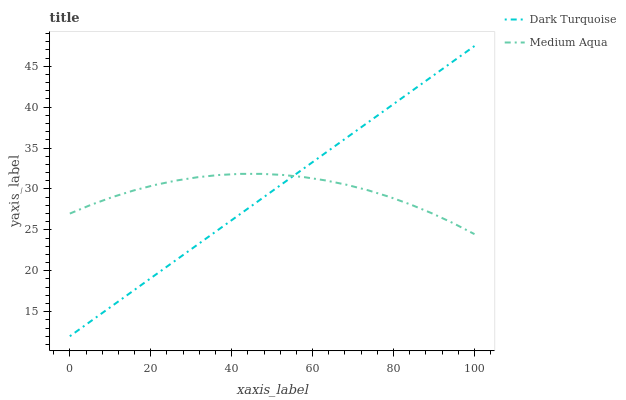Does Dark Turquoise have the minimum area under the curve?
Answer yes or no. Yes. Does Medium Aqua have the maximum area under the curve?
Answer yes or no. Yes. Does Medium Aqua have the minimum area under the curve?
Answer yes or no. No. Is Dark Turquoise the smoothest?
Answer yes or no. Yes. Is Medium Aqua the roughest?
Answer yes or no. Yes. Is Medium Aqua the smoothest?
Answer yes or no. No. Does Dark Turquoise have the lowest value?
Answer yes or no. Yes. Does Medium Aqua have the lowest value?
Answer yes or no. No. Does Dark Turquoise have the highest value?
Answer yes or no. Yes. Does Medium Aqua have the highest value?
Answer yes or no. No. Does Medium Aqua intersect Dark Turquoise?
Answer yes or no. Yes. Is Medium Aqua less than Dark Turquoise?
Answer yes or no. No. Is Medium Aqua greater than Dark Turquoise?
Answer yes or no. No. 